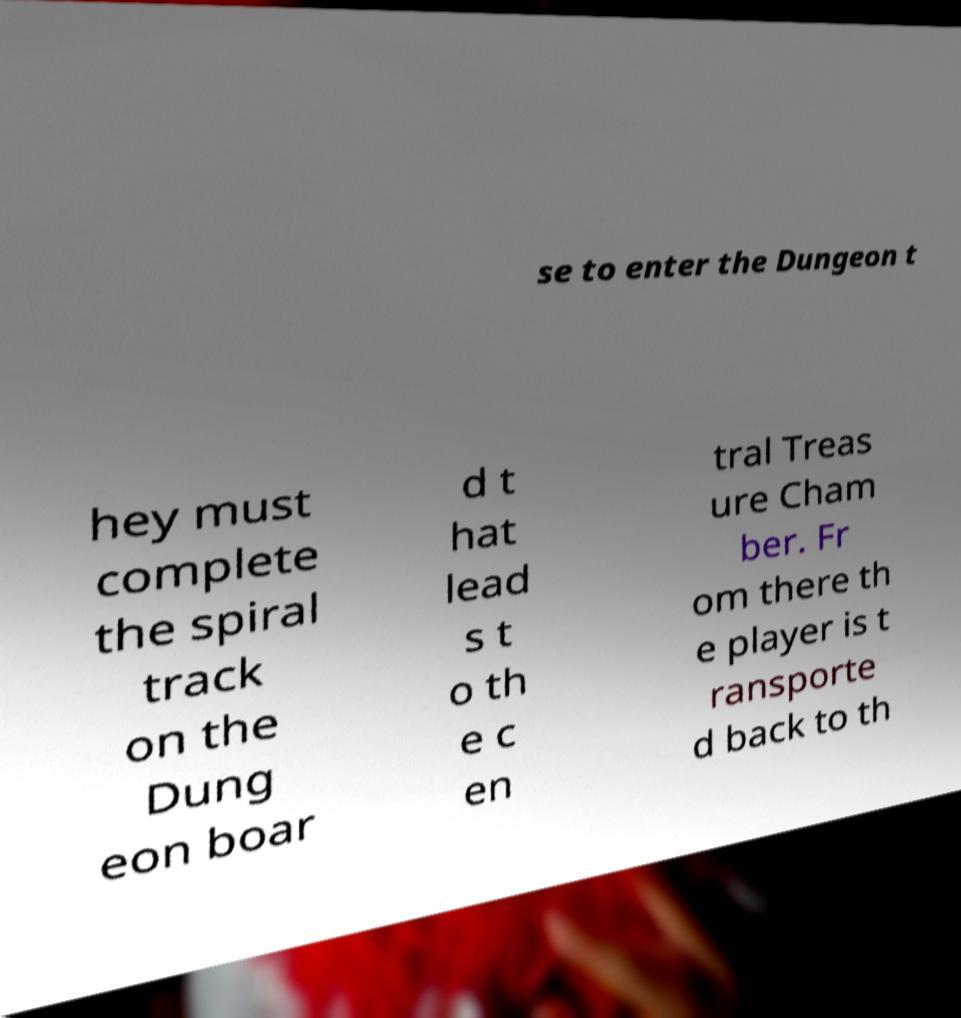There's text embedded in this image that I need extracted. Can you transcribe it verbatim? se to enter the Dungeon t hey must complete the spiral track on the Dung eon boar d t hat lead s t o th e c en tral Treas ure Cham ber. Fr om there th e player is t ransporte d back to th 